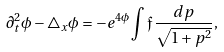Convert formula to latex. <formula><loc_0><loc_0><loc_500><loc_500>\partial _ { t } ^ { 2 } \phi - \bigtriangleup _ { x } \phi = - e ^ { 4 \phi } \int \mathfrak { f } \, \frac { d p } { \sqrt { 1 + p ^ { 2 } } } ,</formula> 